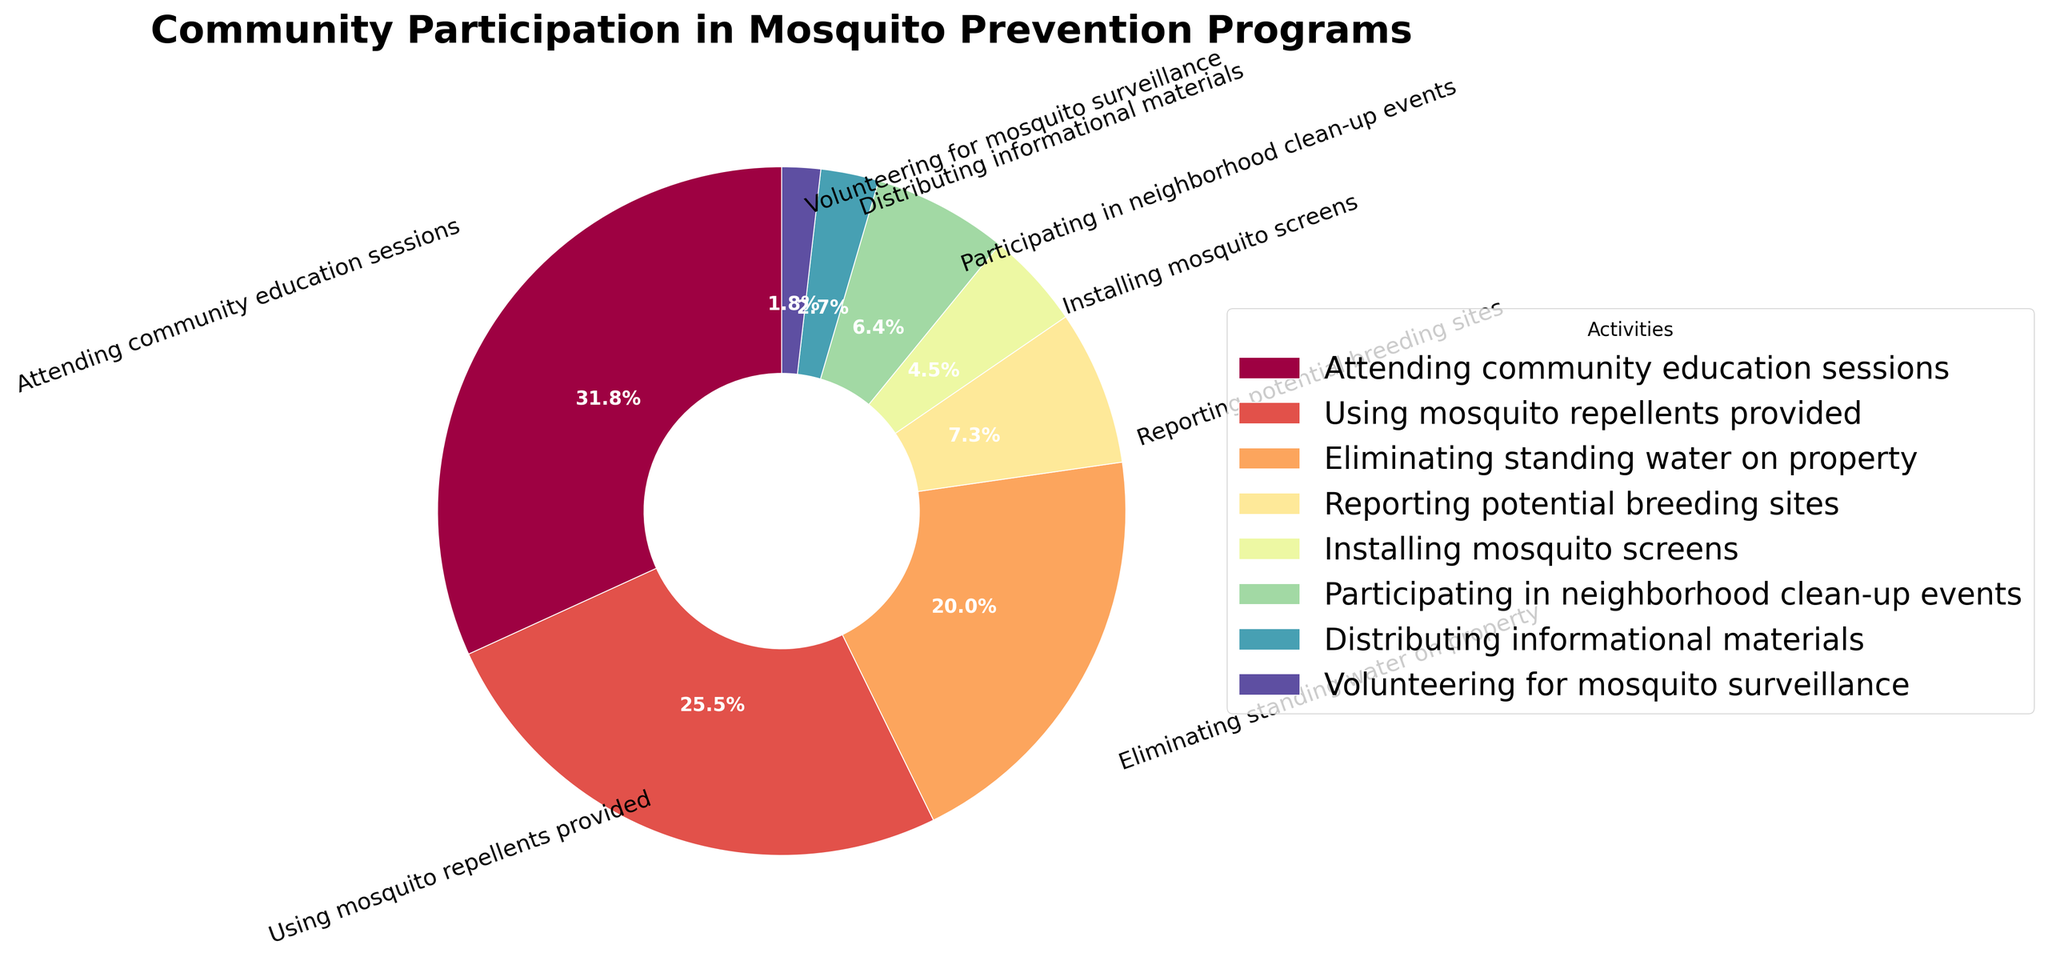Which activity has the highest participation rate? The largest wedge in the pie chart corresponds to the activity "Attending community education sessions," indicated by the percentage label 35%. Thus, this activity has the highest participation rate.
Answer: Attending community education sessions What is the total participation rate for activities involving the distribution and usage of materials? Add the participation rates of activities involving the distribution and usage of materials: "Using mosquito repellents provided" (28%) and "Distributing informational materials" (3%). The sum is 28% + 3% = 31%.
Answer: 31% How does the participation rate for reporting potential breeding sites compare to the rate for eliminating standing water on property? The pie chart shows that the participation rate for "Eliminating standing water on property" is 22%, while "Reporting potential breeding sites" is 8%. Therefore, the rate for the former is significantly higher (22% vs. 8%).
Answer: Higher What is the combined participation rate of activities with less than 10% involvement? Identify and sum the participation rates of activities with less than 10%: "Reporting potential breeding sites" (8%), "Installing mosquito screens" (5%), "Participating in neighborhood clean-up events" (7%), "Distributing informational materials" (3%), "Volunteering for mosquito surveillance" (2%). The total is 8% + 5% + 7% + 3% + 2% = 25%.
Answer: 25% What is the smallest participation rate, and which activity does it correspond to? The smallest wedge in the pie chart shows the activity "Volunteering for mosquito surveillance," indicated by the percentage label 2%. Thus, this activity has the smallest participation rate.
Answer: Volunteering for mosquito surveillance How many activities have a participation rate greater than or equal to 20%? Count the activities with participation rates of 20% or more: "Attending community education sessions" (35%), "Using mosquito repellents provided" (28%), and "Eliminating standing water on property" (22%). There are 3 such activities.
Answer: 3 Which sections of the pie are visually closest in size? The sections "Reporting potential breeding sites" (8%) and "Participating in neighborhood clean-up events" (7%) appear closest in size, as the difference between their participation rates is just 1%.
Answer: Reporting potential breeding sites and Participating in neighborhood clean-up events What is the average participation rate for all the activities? To find the average, sum all participation rates: 35% (Attending community education sessions) + 28% (Using mosquito repellents provided) + 22% (Eliminating standing water on property) + 8% (Reporting potential breeding sites) + 5% (Installing mosquito screens) + 7% (Participating in neighborhood clean-up events) + 3% (Distributing informational materials) + 2% (Volunteering for mosquito surveillance) = 110%. Then, divide by the number of activities (8). The average is 110% / 8 = 13.75%.
Answer: 13.75% What percentage of overall participation is represented by the activities related to physical measures against mosquitoes? Sum the participation rates of activities involving physical measures against mosquitoes, such as "Eliminating standing water on property" (22%), "Installing mosquito screens" (5%), and "Participating in neighborhood clean-up events" (7%). The total is 22% + 5% + 7% = 34%.
Answer: 34% How does the participation in mosquito repellent usage compare to mosquito screens installation in terms of percentage? The participation rates for "Using mosquito repellents provided" is 28%, whereas for "Installing mosquito screens" it is 5%. Thus, the participation rate for mosquito repellent usage is significantly higher than for mosquito screen installation (28% vs. 5%).
Answer: Higher 